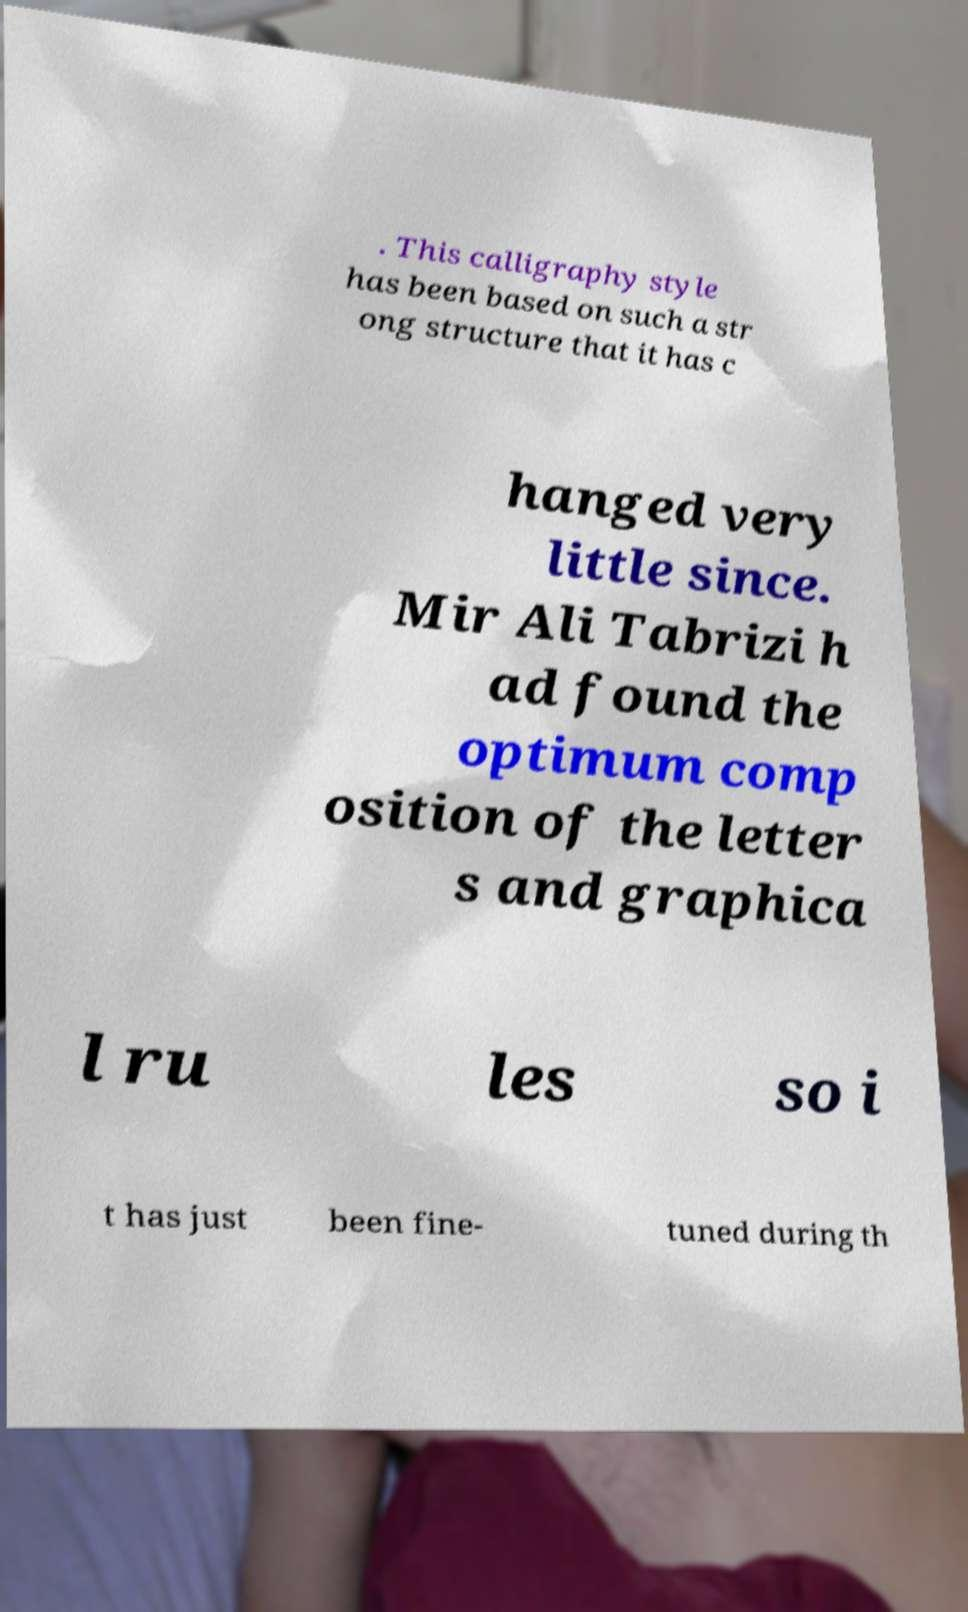Can you accurately transcribe the text from the provided image for me? . This calligraphy style has been based on such a str ong structure that it has c hanged very little since. Mir Ali Tabrizi h ad found the optimum comp osition of the letter s and graphica l ru les so i t has just been fine- tuned during th 